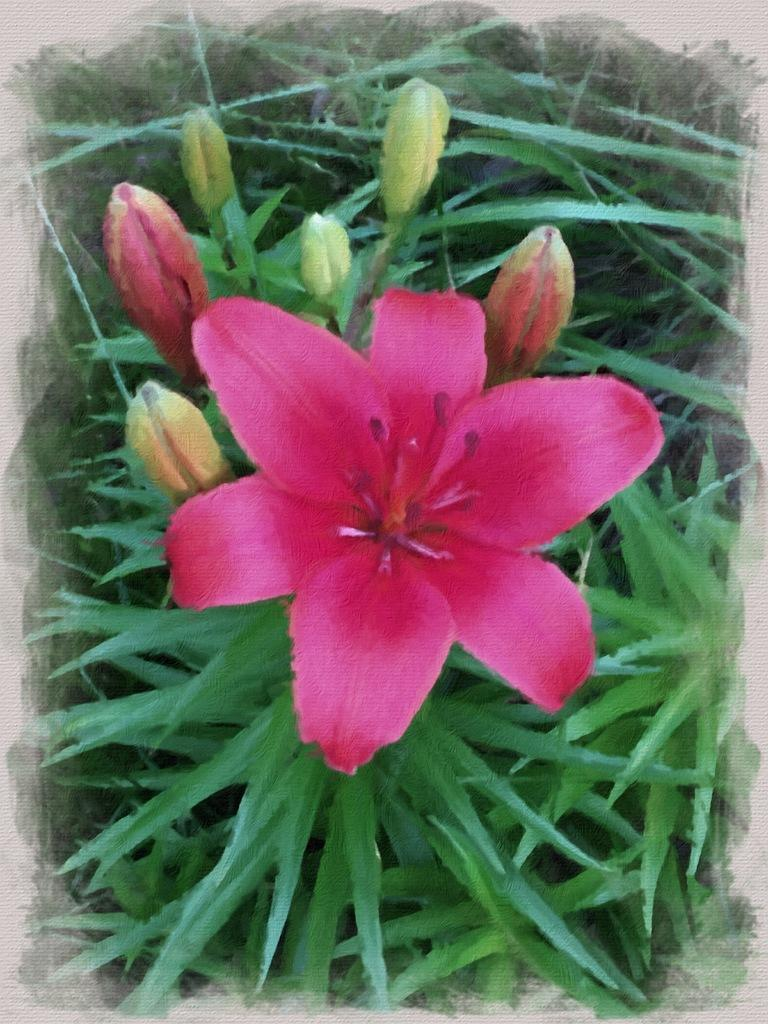What type of plant can be seen in the image? There is a flower in the image. Are there any unopened parts of the plant visible? Yes, there are buds in the image. What part of the plant is visible at the bottom of the image? There are leaves at the bottom of the image. How many chickens are playing with the toys in the image? There are no chickens or toys present in the image; it features a flower with buds and leaves. What language is spoken by the plant in the image? Plants do not speak any language, so this question cannot be answered. 